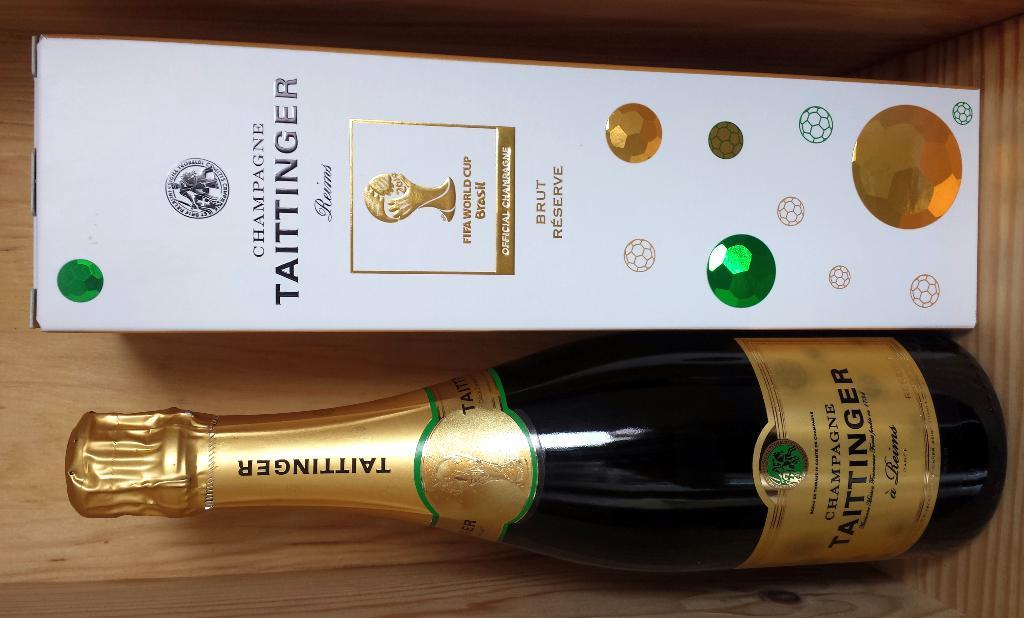What kind of alcohol is this?
Offer a terse response. Champagne. 